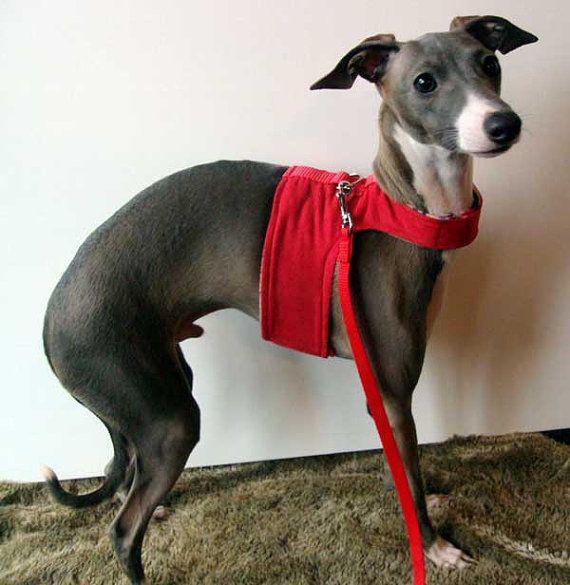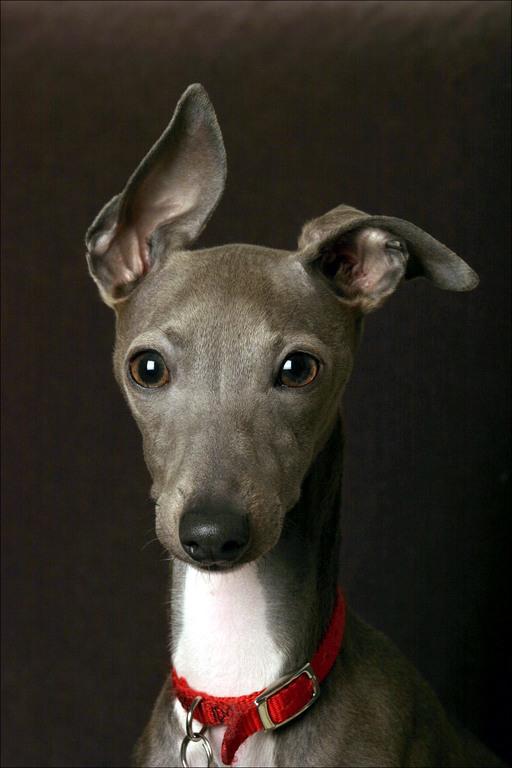The first image is the image on the left, the second image is the image on the right. Considering the images on both sides, is "At least one of the dogs is on a leash." valid? Answer yes or no. Yes. The first image is the image on the left, the second image is the image on the right. Examine the images to the left and right. Is the description "At least one greyhound is wearing something red." accurate? Answer yes or no. Yes. 